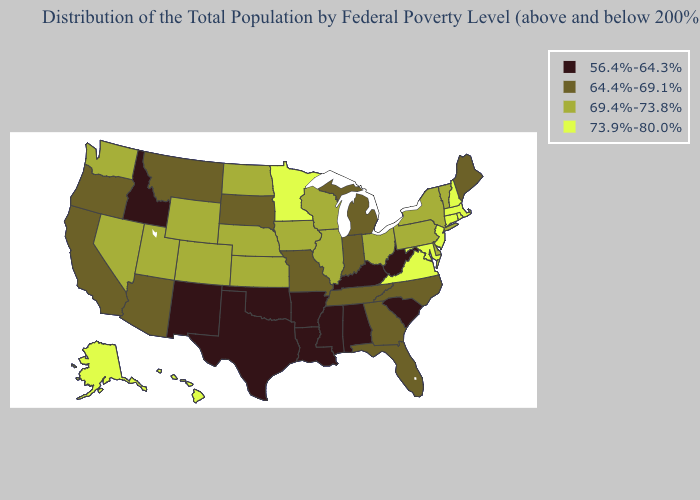Among the states that border Pennsylvania , which have the highest value?
Keep it brief. Maryland, New Jersey. Does Wisconsin have the lowest value in the MidWest?
Write a very short answer. No. Name the states that have a value in the range 64.4%-69.1%?
Concise answer only. Arizona, California, Florida, Georgia, Indiana, Maine, Michigan, Missouri, Montana, North Carolina, Oregon, South Dakota, Tennessee. Name the states that have a value in the range 64.4%-69.1%?
Answer briefly. Arizona, California, Florida, Georgia, Indiana, Maine, Michigan, Missouri, Montana, North Carolina, Oregon, South Dakota, Tennessee. Among the states that border Utah , which have the highest value?
Keep it brief. Colorado, Nevada, Wyoming. Among the states that border Montana , which have the lowest value?
Write a very short answer. Idaho. What is the highest value in states that border Missouri?
Short answer required. 69.4%-73.8%. Name the states that have a value in the range 73.9%-80.0%?
Quick response, please. Alaska, Connecticut, Hawaii, Maryland, Massachusetts, Minnesota, New Hampshire, New Jersey, Rhode Island, Virginia. What is the lowest value in states that border Nebraska?
Write a very short answer. 64.4%-69.1%. What is the lowest value in states that border Idaho?
Give a very brief answer. 64.4%-69.1%. Does Montana have a lower value than Missouri?
Quick response, please. No. What is the lowest value in the Northeast?
Quick response, please. 64.4%-69.1%. Name the states that have a value in the range 69.4%-73.8%?
Answer briefly. Colorado, Delaware, Illinois, Iowa, Kansas, Nebraska, Nevada, New York, North Dakota, Ohio, Pennsylvania, Utah, Vermont, Washington, Wisconsin, Wyoming. Name the states that have a value in the range 64.4%-69.1%?
Short answer required. Arizona, California, Florida, Georgia, Indiana, Maine, Michigan, Missouri, Montana, North Carolina, Oregon, South Dakota, Tennessee. 